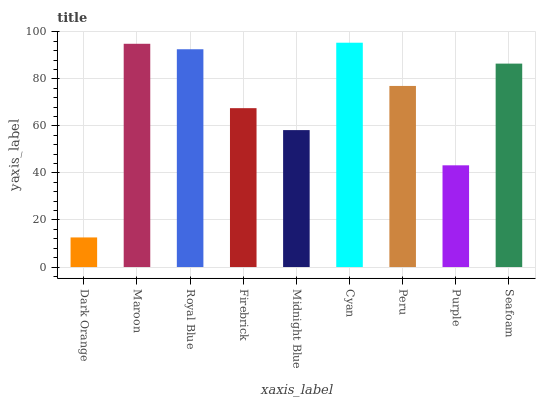Is Maroon the minimum?
Answer yes or no. No. Is Maroon the maximum?
Answer yes or no. No. Is Maroon greater than Dark Orange?
Answer yes or no. Yes. Is Dark Orange less than Maroon?
Answer yes or no. Yes. Is Dark Orange greater than Maroon?
Answer yes or no. No. Is Maroon less than Dark Orange?
Answer yes or no. No. Is Peru the high median?
Answer yes or no. Yes. Is Peru the low median?
Answer yes or no. Yes. Is Purple the high median?
Answer yes or no. No. Is Seafoam the low median?
Answer yes or no. No. 